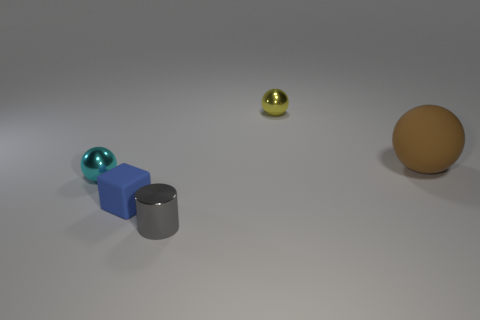Is the color of the sphere on the right side of the small yellow sphere the same as the shiny sphere that is behind the cyan ball?
Keep it short and to the point. No. How many tiny balls are there?
Keep it short and to the point. 2. Are there any small shiny things right of the cyan metallic thing?
Your answer should be very brief. Yes. Does the ball that is in front of the big brown matte sphere have the same material as the thing that is in front of the blue object?
Provide a short and direct response. Yes. Are there fewer small cyan objects that are in front of the gray cylinder than tiny matte things?
Provide a succinct answer. Yes. There is a small metallic object that is left of the tiny gray object; what color is it?
Your answer should be compact. Cyan. What material is the small sphere that is right of the small metallic object that is on the left side of the cylinder?
Make the answer very short. Metal. Is there a cyan rubber object that has the same size as the blue thing?
Make the answer very short. No. How many objects are blue rubber blocks in front of the brown rubber sphere or matte things that are in front of the big ball?
Provide a succinct answer. 1. There is a metal thing that is to the left of the small blue object; does it have the same size as the shiny thing in front of the cyan metallic sphere?
Your answer should be compact. Yes. 